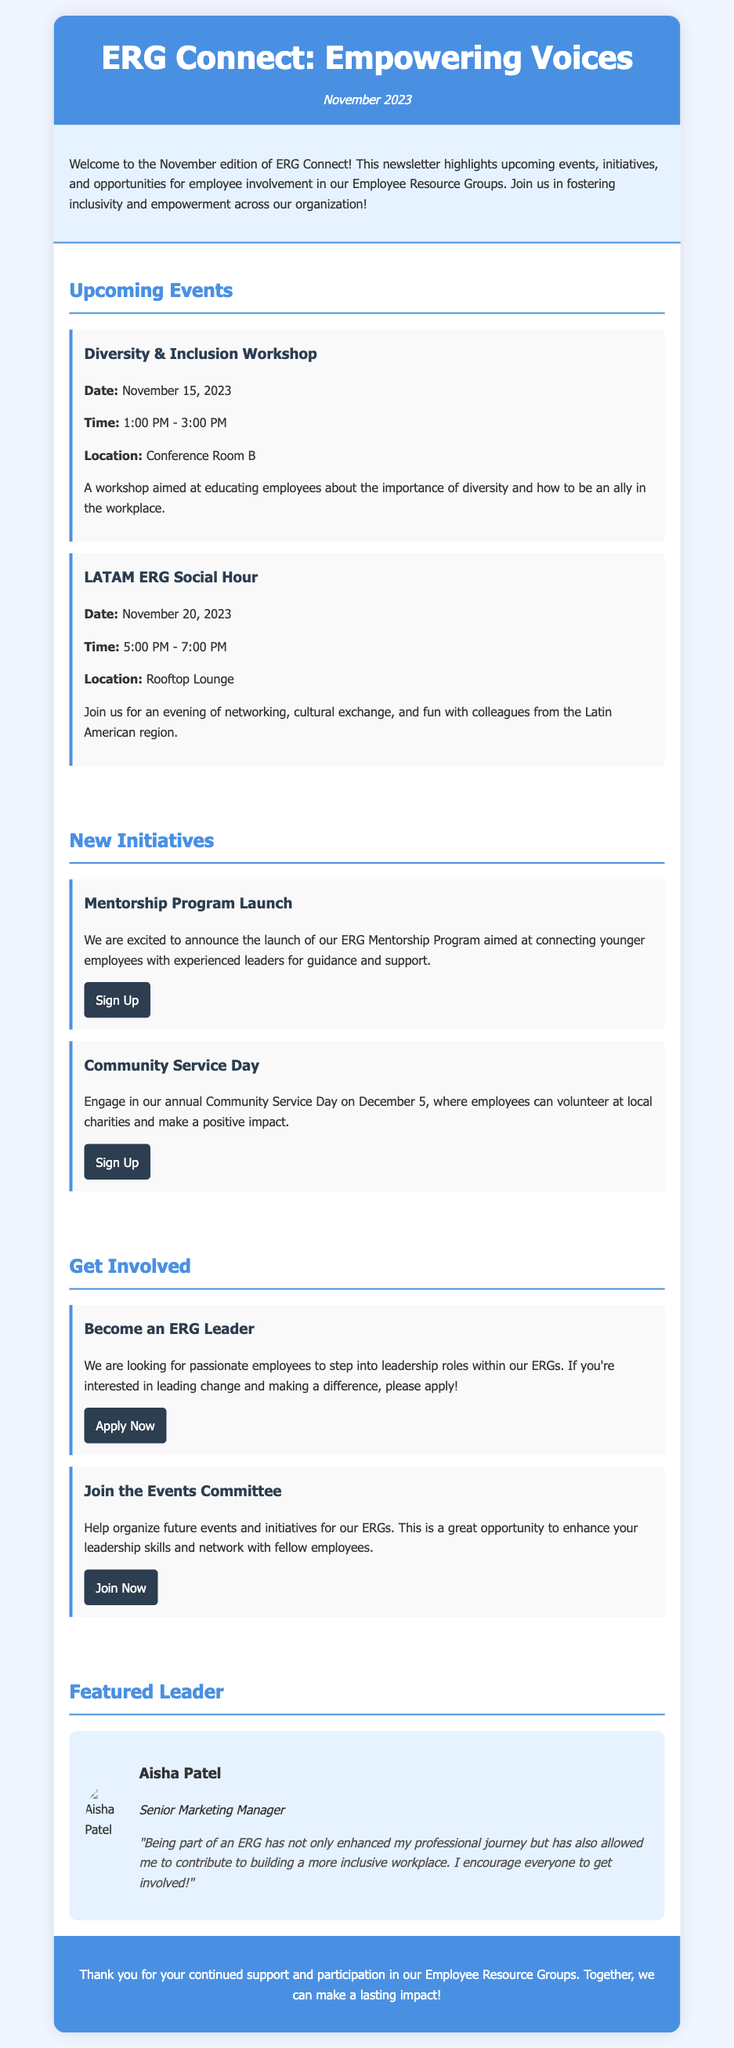What is the title of the newsletter? The title of the newsletter is prominently displayed at the top of the document, which is "ERG Connect: Empowering Voices."
Answer: ERG Connect: Empowering Voices What is the date of the newsletter? The date is mentioned right below the title in the header section, indicating the release month and year.
Answer: November 2023 What is the first event mentioned in the newsletter? The first event is listed under the Upcoming Events section, outlining the details of the event.
Answer: Diversity & Inclusion Workshop What is the date of the Community Service Day? The date for the Community Service Day is specified in the New Initiatives section of the document.
Answer: December 5 Who is the featured leader in this newsletter? The featured leader is highlighted in the Featured Leader section, providing personal insights and encouragement.
Answer: Aisha Patel What opportunity does the newsletter provide for employees? The newsletter offers various ways for employees to get involved, and one specific role is highlighted for participation.
Answer: Become an ERG Leader How long is the Diversity & Inclusion Workshop scheduled to last? The duration of the workshop is specified in the event details, indicating the timing of the event.
Answer: 2 hours What quote is attributed to Aisha Patel? Aisha Patel shares a personal reflection that underscores her experience with the ERG, emphasizing its importance.
Answer: "Being part of an ERG has not only enhanced my professional journey but has also allowed me to contribute to building a more inclusive workplace. I encourage everyone to get involved!" 